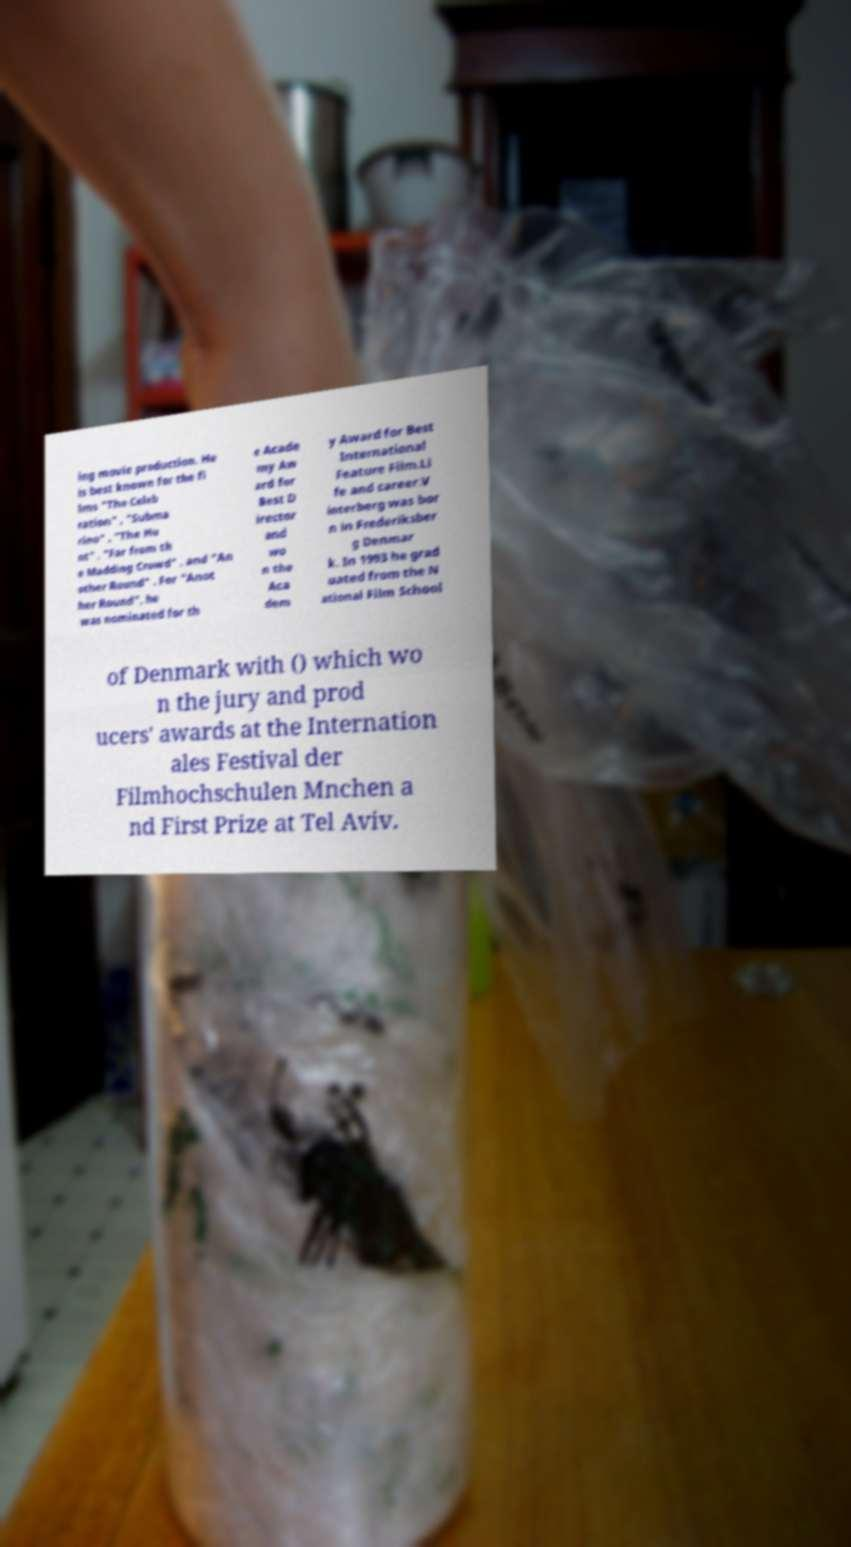There's text embedded in this image that I need extracted. Can you transcribe it verbatim? ing movie production. He is best known for the fi lms "The Celeb ration" , "Subma rino" , "The Hu nt" , "Far from th e Madding Crowd" , and "An other Round" . For "Anot her Round", he was nominated for th e Acade my Aw ard for Best D irector and wo n the Aca dem y Award for Best International Feature Film.Li fe and career.V interberg was bor n in Frederiksber g Denmar k. In 1993 he grad uated from the N ational Film School of Denmark with () which wo n the jury and prod ucers' awards at the Internation ales Festival der Filmhochschulen Mnchen a nd First Prize at Tel Aviv. 